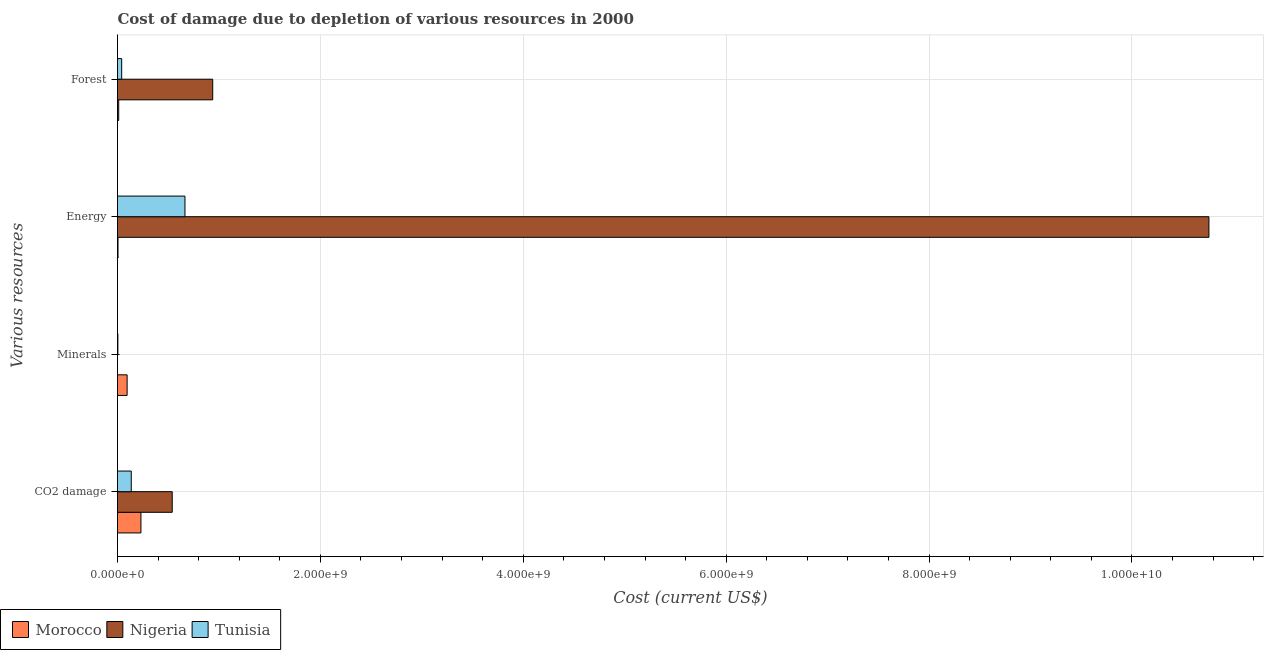How many different coloured bars are there?
Keep it short and to the point. 3. Are the number of bars per tick equal to the number of legend labels?
Offer a very short reply. Yes. Are the number of bars on each tick of the Y-axis equal?
Keep it short and to the point. Yes. How many bars are there on the 4th tick from the top?
Make the answer very short. 3. What is the label of the 4th group of bars from the top?
Make the answer very short. CO2 damage. What is the cost of damage due to depletion of coal in Morocco?
Your answer should be compact. 2.31e+08. Across all countries, what is the maximum cost of damage due to depletion of minerals?
Keep it short and to the point. 9.48e+07. Across all countries, what is the minimum cost of damage due to depletion of coal?
Make the answer very short. 1.36e+08. In which country was the cost of damage due to depletion of forests maximum?
Ensure brevity in your answer.  Nigeria. In which country was the cost of damage due to depletion of coal minimum?
Make the answer very short. Tunisia. What is the total cost of damage due to depletion of minerals in the graph?
Offer a very short reply. 9.86e+07. What is the difference between the cost of damage due to depletion of minerals in Nigeria and that in Morocco?
Offer a terse response. -9.47e+07. What is the difference between the cost of damage due to depletion of energy in Tunisia and the cost of damage due to depletion of minerals in Morocco?
Offer a terse response. 5.70e+08. What is the average cost of damage due to depletion of forests per country?
Offer a terse response. 3.31e+08. What is the difference between the cost of damage due to depletion of energy and cost of damage due to depletion of minerals in Tunisia?
Your response must be concise. 6.61e+08. What is the ratio of the cost of damage due to depletion of coal in Nigeria to that in Tunisia?
Your response must be concise. 3.97. Is the cost of damage due to depletion of energy in Nigeria less than that in Morocco?
Offer a terse response. No. What is the difference between the highest and the second highest cost of damage due to depletion of minerals?
Offer a terse response. 9.12e+07. What is the difference between the highest and the lowest cost of damage due to depletion of energy?
Keep it short and to the point. 1.08e+1. In how many countries, is the cost of damage due to depletion of energy greater than the average cost of damage due to depletion of energy taken over all countries?
Your response must be concise. 1. Is the sum of the cost of damage due to depletion of forests in Tunisia and Nigeria greater than the maximum cost of damage due to depletion of minerals across all countries?
Ensure brevity in your answer.  Yes. What does the 1st bar from the top in Energy represents?
Ensure brevity in your answer.  Tunisia. What does the 3rd bar from the bottom in Minerals represents?
Your answer should be very brief. Tunisia. Is it the case that in every country, the sum of the cost of damage due to depletion of coal and cost of damage due to depletion of minerals is greater than the cost of damage due to depletion of energy?
Your answer should be very brief. No. What is the difference between two consecutive major ticks on the X-axis?
Provide a succinct answer. 2.00e+09. How are the legend labels stacked?
Offer a terse response. Horizontal. What is the title of the graph?
Provide a short and direct response. Cost of damage due to depletion of various resources in 2000 . Does "Sudan" appear as one of the legend labels in the graph?
Offer a very short reply. No. What is the label or title of the X-axis?
Offer a terse response. Cost (current US$). What is the label or title of the Y-axis?
Your answer should be very brief. Various resources. What is the Cost (current US$) in Morocco in CO2 damage?
Your answer should be compact. 2.31e+08. What is the Cost (current US$) of Nigeria in CO2 damage?
Provide a short and direct response. 5.39e+08. What is the Cost (current US$) of Tunisia in CO2 damage?
Provide a succinct answer. 1.36e+08. What is the Cost (current US$) in Morocco in Minerals?
Offer a very short reply. 9.48e+07. What is the Cost (current US$) in Nigeria in Minerals?
Keep it short and to the point. 1.37e+05. What is the Cost (current US$) in Tunisia in Minerals?
Your answer should be very brief. 3.63e+06. What is the Cost (current US$) of Morocco in Energy?
Ensure brevity in your answer.  5.01e+06. What is the Cost (current US$) of Nigeria in Energy?
Give a very brief answer. 1.08e+1. What is the Cost (current US$) of Tunisia in Energy?
Provide a succinct answer. 6.65e+08. What is the Cost (current US$) in Morocco in Forest?
Keep it short and to the point. 1.18e+07. What is the Cost (current US$) in Nigeria in Forest?
Your answer should be compact. 9.39e+08. What is the Cost (current US$) in Tunisia in Forest?
Offer a very short reply. 4.13e+07. Across all Various resources, what is the maximum Cost (current US$) in Morocco?
Offer a very short reply. 2.31e+08. Across all Various resources, what is the maximum Cost (current US$) in Nigeria?
Keep it short and to the point. 1.08e+1. Across all Various resources, what is the maximum Cost (current US$) in Tunisia?
Give a very brief answer. 6.65e+08. Across all Various resources, what is the minimum Cost (current US$) of Morocco?
Your answer should be very brief. 5.01e+06. Across all Various resources, what is the minimum Cost (current US$) of Nigeria?
Make the answer very short. 1.37e+05. Across all Various resources, what is the minimum Cost (current US$) in Tunisia?
Offer a very short reply. 3.63e+06. What is the total Cost (current US$) of Morocco in the graph?
Your response must be concise. 3.43e+08. What is the total Cost (current US$) in Nigeria in the graph?
Your answer should be very brief. 1.22e+1. What is the total Cost (current US$) in Tunisia in the graph?
Your response must be concise. 8.45e+08. What is the difference between the Cost (current US$) in Morocco in CO2 damage and that in Minerals?
Your answer should be very brief. 1.36e+08. What is the difference between the Cost (current US$) of Nigeria in CO2 damage and that in Minerals?
Provide a succinct answer. 5.39e+08. What is the difference between the Cost (current US$) of Tunisia in CO2 damage and that in Minerals?
Offer a very short reply. 1.32e+08. What is the difference between the Cost (current US$) in Morocco in CO2 damage and that in Energy?
Keep it short and to the point. 2.26e+08. What is the difference between the Cost (current US$) in Nigeria in CO2 damage and that in Energy?
Your answer should be compact. -1.02e+1. What is the difference between the Cost (current US$) of Tunisia in CO2 damage and that in Energy?
Your answer should be very brief. -5.29e+08. What is the difference between the Cost (current US$) of Morocco in CO2 damage and that in Forest?
Offer a very short reply. 2.19e+08. What is the difference between the Cost (current US$) in Nigeria in CO2 damage and that in Forest?
Make the answer very short. -3.99e+08. What is the difference between the Cost (current US$) of Tunisia in CO2 damage and that in Forest?
Keep it short and to the point. 9.44e+07. What is the difference between the Cost (current US$) in Morocco in Minerals and that in Energy?
Offer a very short reply. 8.98e+07. What is the difference between the Cost (current US$) in Nigeria in Minerals and that in Energy?
Keep it short and to the point. -1.08e+1. What is the difference between the Cost (current US$) in Tunisia in Minerals and that in Energy?
Provide a succinct answer. -6.61e+08. What is the difference between the Cost (current US$) of Morocco in Minerals and that in Forest?
Offer a terse response. 8.30e+07. What is the difference between the Cost (current US$) in Nigeria in Minerals and that in Forest?
Give a very brief answer. -9.38e+08. What is the difference between the Cost (current US$) in Tunisia in Minerals and that in Forest?
Ensure brevity in your answer.  -3.76e+07. What is the difference between the Cost (current US$) in Morocco in Energy and that in Forest?
Make the answer very short. -6.78e+06. What is the difference between the Cost (current US$) in Nigeria in Energy and that in Forest?
Your answer should be compact. 9.82e+09. What is the difference between the Cost (current US$) in Tunisia in Energy and that in Forest?
Offer a very short reply. 6.24e+08. What is the difference between the Cost (current US$) of Morocco in CO2 damage and the Cost (current US$) of Nigeria in Minerals?
Your answer should be very brief. 2.31e+08. What is the difference between the Cost (current US$) in Morocco in CO2 damage and the Cost (current US$) in Tunisia in Minerals?
Provide a succinct answer. 2.27e+08. What is the difference between the Cost (current US$) of Nigeria in CO2 damage and the Cost (current US$) of Tunisia in Minerals?
Keep it short and to the point. 5.36e+08. What is the difference between the Cost (current US$) of Morocco in CO2 damage and the Cost (current US$) of Nigeria in Energy?
Provide a succinct answer. -1.05e+1. What is the difference between the Cost (current US$) of Morocco in CO2 damage and the Cost (current US$) of Tunisia in Energy?
Your answer should be compact. -4.34e+08. What is the difference between the Cost (current US$) of Nigeria in CO2 damage and the Cost (current US$) of Tunisia in Energy?
Give a very brief answer. -1.26e+08. What is the difference between the Cost (current US$) of Morocco in CO2 damage and the Cost (current US$) of Nigeria in Forest?
Keep it short and to the point. -7.08e+08. What is the difference between the Cost (current US$) in Morocco in CO2 damage and the Cost (current US$) in Tunisia in Forest?
Make the answer very short. 1.90e+08. What is the difference between the Cost (current US$) in Nigeria in CO2 damage and the Cost (current US$) in Tunisia in Forest?
Make the answer very short. 4.98e+08. What is the difference between the Cost (current US$) in Morocco in Minerals and the Cost (current US$) in Nigeria in Energy?
Your answer should be very brief. -1.07e+1. What is the difference between the Cost (current US$) of Morocco in Minerals and the Cost (current US$) of Tunisia in Energy?
Keep it short and to the point. -5.70e+08. What is the difference between the Cost (current US$) of Nigeria in Minerals and the Cost (current US$) of Tunisia in Energy?
Offer a very short reply. -6.65e+08. What is the difference between the Cost (current US$) of Morocco in Minerals and the Cost (current US$) of Nigeria in Forest?
Offer a terse response. -8.44e+08. What is the difference between the Cost (current US$) in Morocco in Minerals and the Cost (current US$) in Tunisia in Forest?
Offer a very short reply. 5.35e+07. What is the difference between the Cost (current US$) in Nigeria in Minerals and the Cost (current US$) in Tunisia in Forest?
Your response must be concise. -4.11e+07. What is the difference between the Cost (current US$) in Morocco in Energy and the Cost (current US$) in Nigeria in Forest?
Your response must be concise. -9.34e+08. What is the difference between the Cost (current US$) in Morocco in Energy and the Cost (current US$) in Tunisia in Forest?
Provide a short and direct response. -3.62e+07. What is the difference between the Cost (current US$) in Nigeria in Energy and the Cost (current US$) in Tunisia in Forest?
Your answer should be very brief. 1.07e+1. What is the average Cost (current US$) in Morocco per Various resources?
Offer a terse response. 8.56e+07. What is the average Cost (current US$) of Nigeria per Various resources?
Provide a succinct answer. 3.06e+09. What is the average Cost (current US$) in Tunisia per Various resources?
Provide a succinct answer. 2.11e+08. What is the difference between the Cost (current US$) of Morocco and Cost (current US$) of Nigeria in CO2 damage?
Make the answer very short. -3.08e+08. What is the difference between the Cost (current US$) in Morocco and Cost (current US$) in Tunisia in CO2 damage?
Your answer should be very brief. 9.52e+07. What is the difference between the Cost (current US$) of Nigeria and Cost (current US$) of Tunisia in CO2 damage?
Give a very brief answer. 4.04e+08. What is the difference between the Cost (current US$) of Morocco and Cost (current US$) of Nigeria in Minerals?
Make the answer very short. 9.47e+07. What is the difference between the Cost (current US$) in Morocco and Cost (current US$) in Tunisia in Minerals?
Provide a short and direct response. 9.12e+07. What is the difference between the Cost (current US$) in Nigeria and Cost (current US$) in Tunisia in Minerals?
Ensure brevity in your answer.  -3.50e+06. What is the difference between the Cost (current US$) of Morocco and Cost (current US$) of Nigeria in Energy?
Offer a very short reply. -1.08e+1. What is the difference between the Cost (current US$) in Morocco and Cost (current US$) in Tunisia in Energy?
Give a very brief answer. -6.60e+08. What is the difference between the Cost (current US$) of Nigeria and Cost (current US$) of Tunisia in Energy?
Give a very brief answer. 1.01e+1. What is the difference between the Cost (current US$) of Morocco and Cost (current US$) of Nigeria in Forest?
Provide a succinct answer. -9.27e+08. What is the difference between the Cost (current US$) in Morocco and Cost (current US$) in Tunisia in Forest?
Offer a terse response. -2.95e+07. What is the difference between the Cost (current US$) in Nigeria and Cost (current US$) in Tunisia in Forest?
Your response must be concise. 8.97e+08. What is the ratio of the Cost (current US$) of Morocco in CO2 damage to that in Minerals?
Your response must be concise. 2.44. What is the ratio of the Cost (current US$) in Nigeria in CO2 damage to that in Minerals?
Your response must be concise. 3930.4. What is the ratio of the Cost (current US$) of Tunisia in CO2 damage to that in Minerals?
Your answer should be compact. 37.33. What is the ratio of the Cost (current US$) in Morocco in CO2 damage to that in Energy?
Offer a terse response. 46.05. What is the ratio of the Cost (current US$) of Nigeria in CO2 damage to that in Energy?
Keep it short and to the point. 0.05. What is the ratio of the Cost (current US$) of Tunisia in CO2 damage to that in Energy?
Ensure brevity in your answer.  0.2. What is the ratio of the Cost (current US$) in Morocco in CO2 damage to that in Forest?
Offer a terse response. 19.58. What is the ratio of the Cost (current US$) of Nigeria in CO2 damage to that in Forest?
Your response must be concise. 0.57. What is the ratio of the Cost (current US$) in Tunisia in CO2 damage to that in Forest?
Ensure brevity in your answer.  3.29. What is the ratio of the Cost (current US$) of Morocco in Minerals to that in Energy?
Make the answer very short. 18.9. What is the ratio of the Cost (current US$) of Nigeria in Minerals to that in Energy?
Give a very brief answer. 0. What is the ratio of the Cost (current US$) of Tunisia in Minerals to that in Energy?
Ensure brevity in your answer.  0.01. What is the ratio of the Cost (current US$) of Morocco in Minerals to that in Forest?
Your answer should be compact. 8.04. What is the ratio of the Cost (current US$) in Nigeria in Minerals to that in Forest?
Make the answer very short. 0. What is the ratio of the Cost (current US$) in Tunisia in Minerals to that in Forest?
Offer a very short reply. 0.09. What is the ratio of the Cost (current US$) of Morocco in Energy to that in Forest?
Offer a very short reply. 0.43. What is the ratio of the Cost (current US$) of Nigeria in Energy to that in Forest?
Keep it short and to the point. 11.46. What is the ratio of the Cost (current US$) of Tunisia in Energy to that in Forest?
Give a very brief answer. 16.11. What is the difference between the highest and the second highest Cost (current US$) in Morocco?
Ensure brevity in your answer.  1.36e+08. What is the difference between the highest and the second highest Cost (current US$) in Nigeria?
Your answer should be very brief. 9.82e+09. What is the difference between the highest and the second highest Cost (current US$) of Tunisia?
Offer a terse response. 5.29e+08. What is the difference between the highest and the lowest Cost (current US$) of Morocco?
Your answer should be very brief. 2.26e+08. What is the difference between the highest and the lowest Cost (current US$) of Nigeria?
Offer a very short reply. 1.08e+1. What is the difference between the highest and the lowest Cost (current US$) in Tunisia?
Keep it short and to the point. 6.61e+08. 